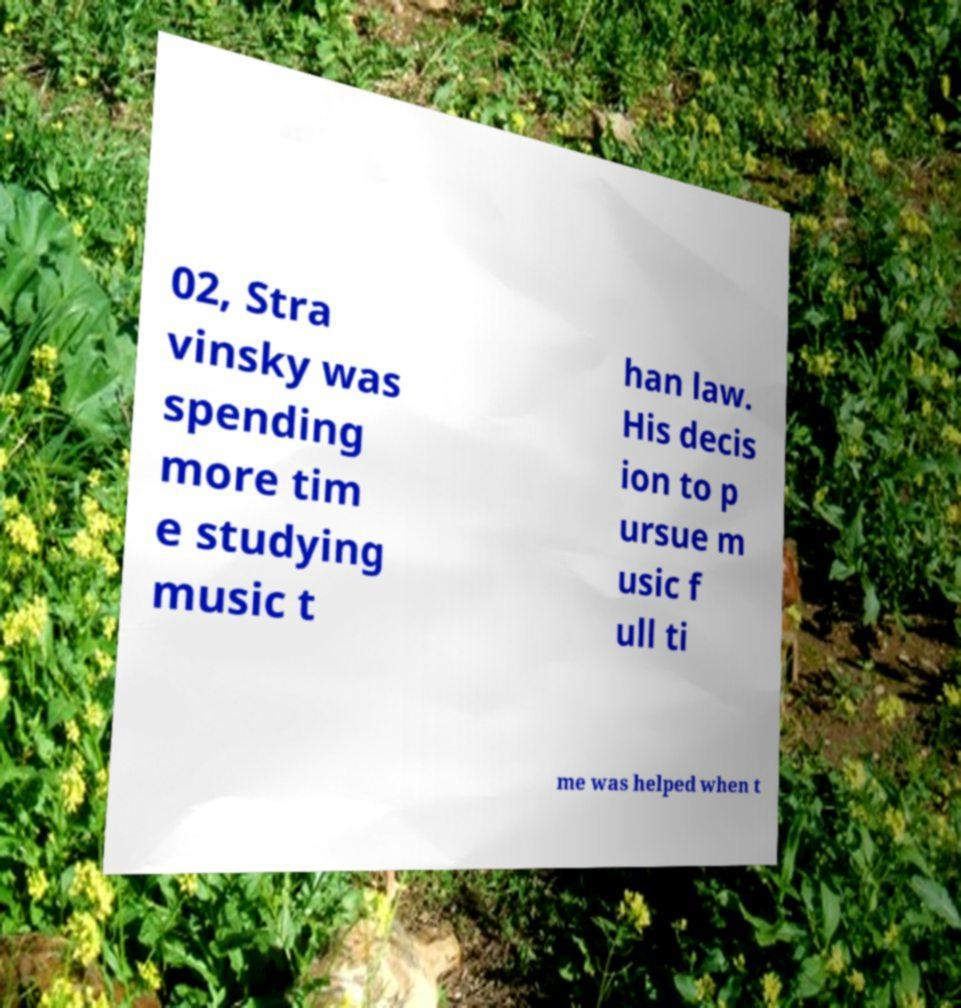What messages or text are displayed in this image? I need them in a readable, typed format. 02, Stra vinsky was spending more tim e studying music t han law. His decis ion to p ursue m usic f ull ti me was helped when t 